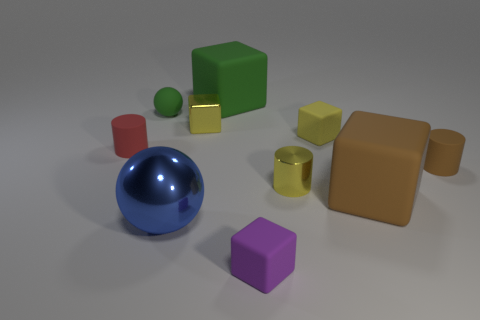Subtract 2 blocks. How many blocks are left? 3 Subtract all gray cylinders. Subtract all purple balls. How many cylinders are left? 3 Subtract all cylinders. How many objects are left? 7 Add 1 blue balls. How many blue balls are left? 2 Add 7 big purple shiny cylinders. How many big purple shiny cylinders exist? 7 Subtract 1 red cylinders. How many objects are left? 9 Subtract all large matte objects. Subtract all brown metallic balls. How many objects are left? 8 